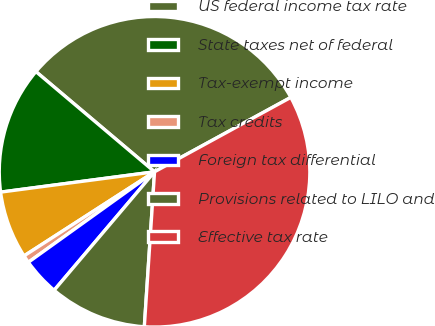Convert chart. <chart><loc_0><loc_0><loc_500><loc_500><pie_chart><fcel>US federal income tax rate<fcel>State taxes net of federal<fcel>Tax-exempt income<fcel>Tax credits<fcel>Foreign tax differential<fcel>Provisions related to LILO and<fcel>Effective tax rate<nl><fcel>30.88%<fcel>13.25%<fcel>7.02%<fcel>0.79%<fcel>3.91%<fcel>10.14%<fcel>34.0%<nl></chart> 